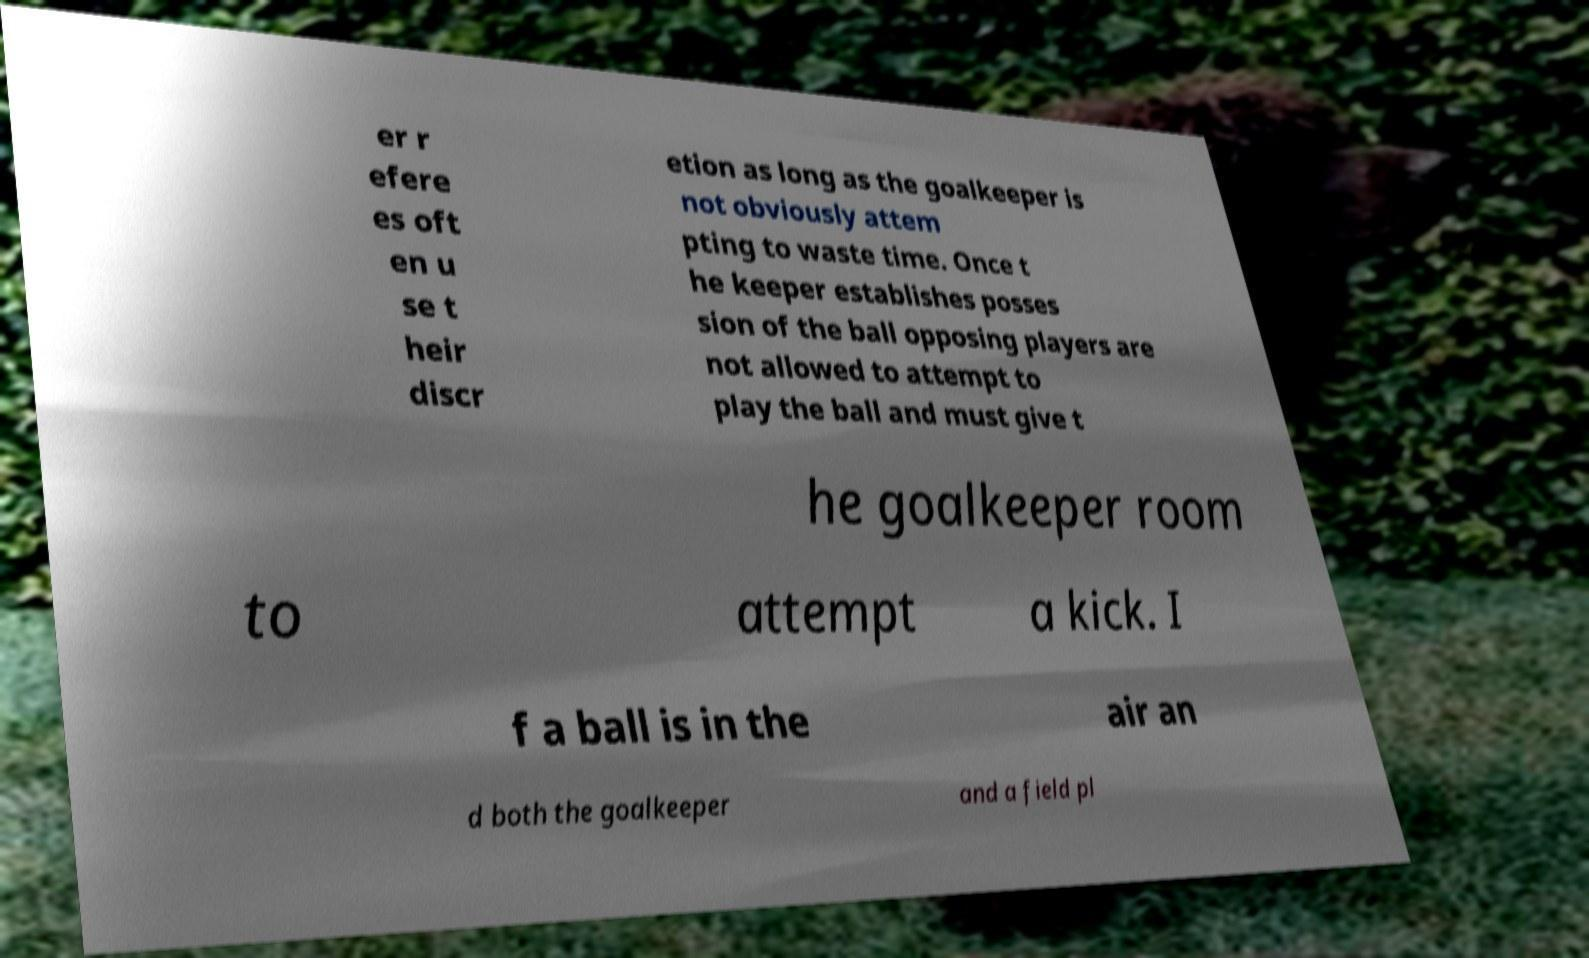Can you accurately transcribe the text from the provided image for me? er r efere es oft en u se t heir discr etion as long as the goalkeeper is not obviously attem pting to waste time. Once t he keeper establishes posses sion of the ball opposing players are not allowed to attempt to play the ball and must give t he goalkeeper room to attempt a kick. I f a ball is in the air an d both the goalkeeper and a field pl 